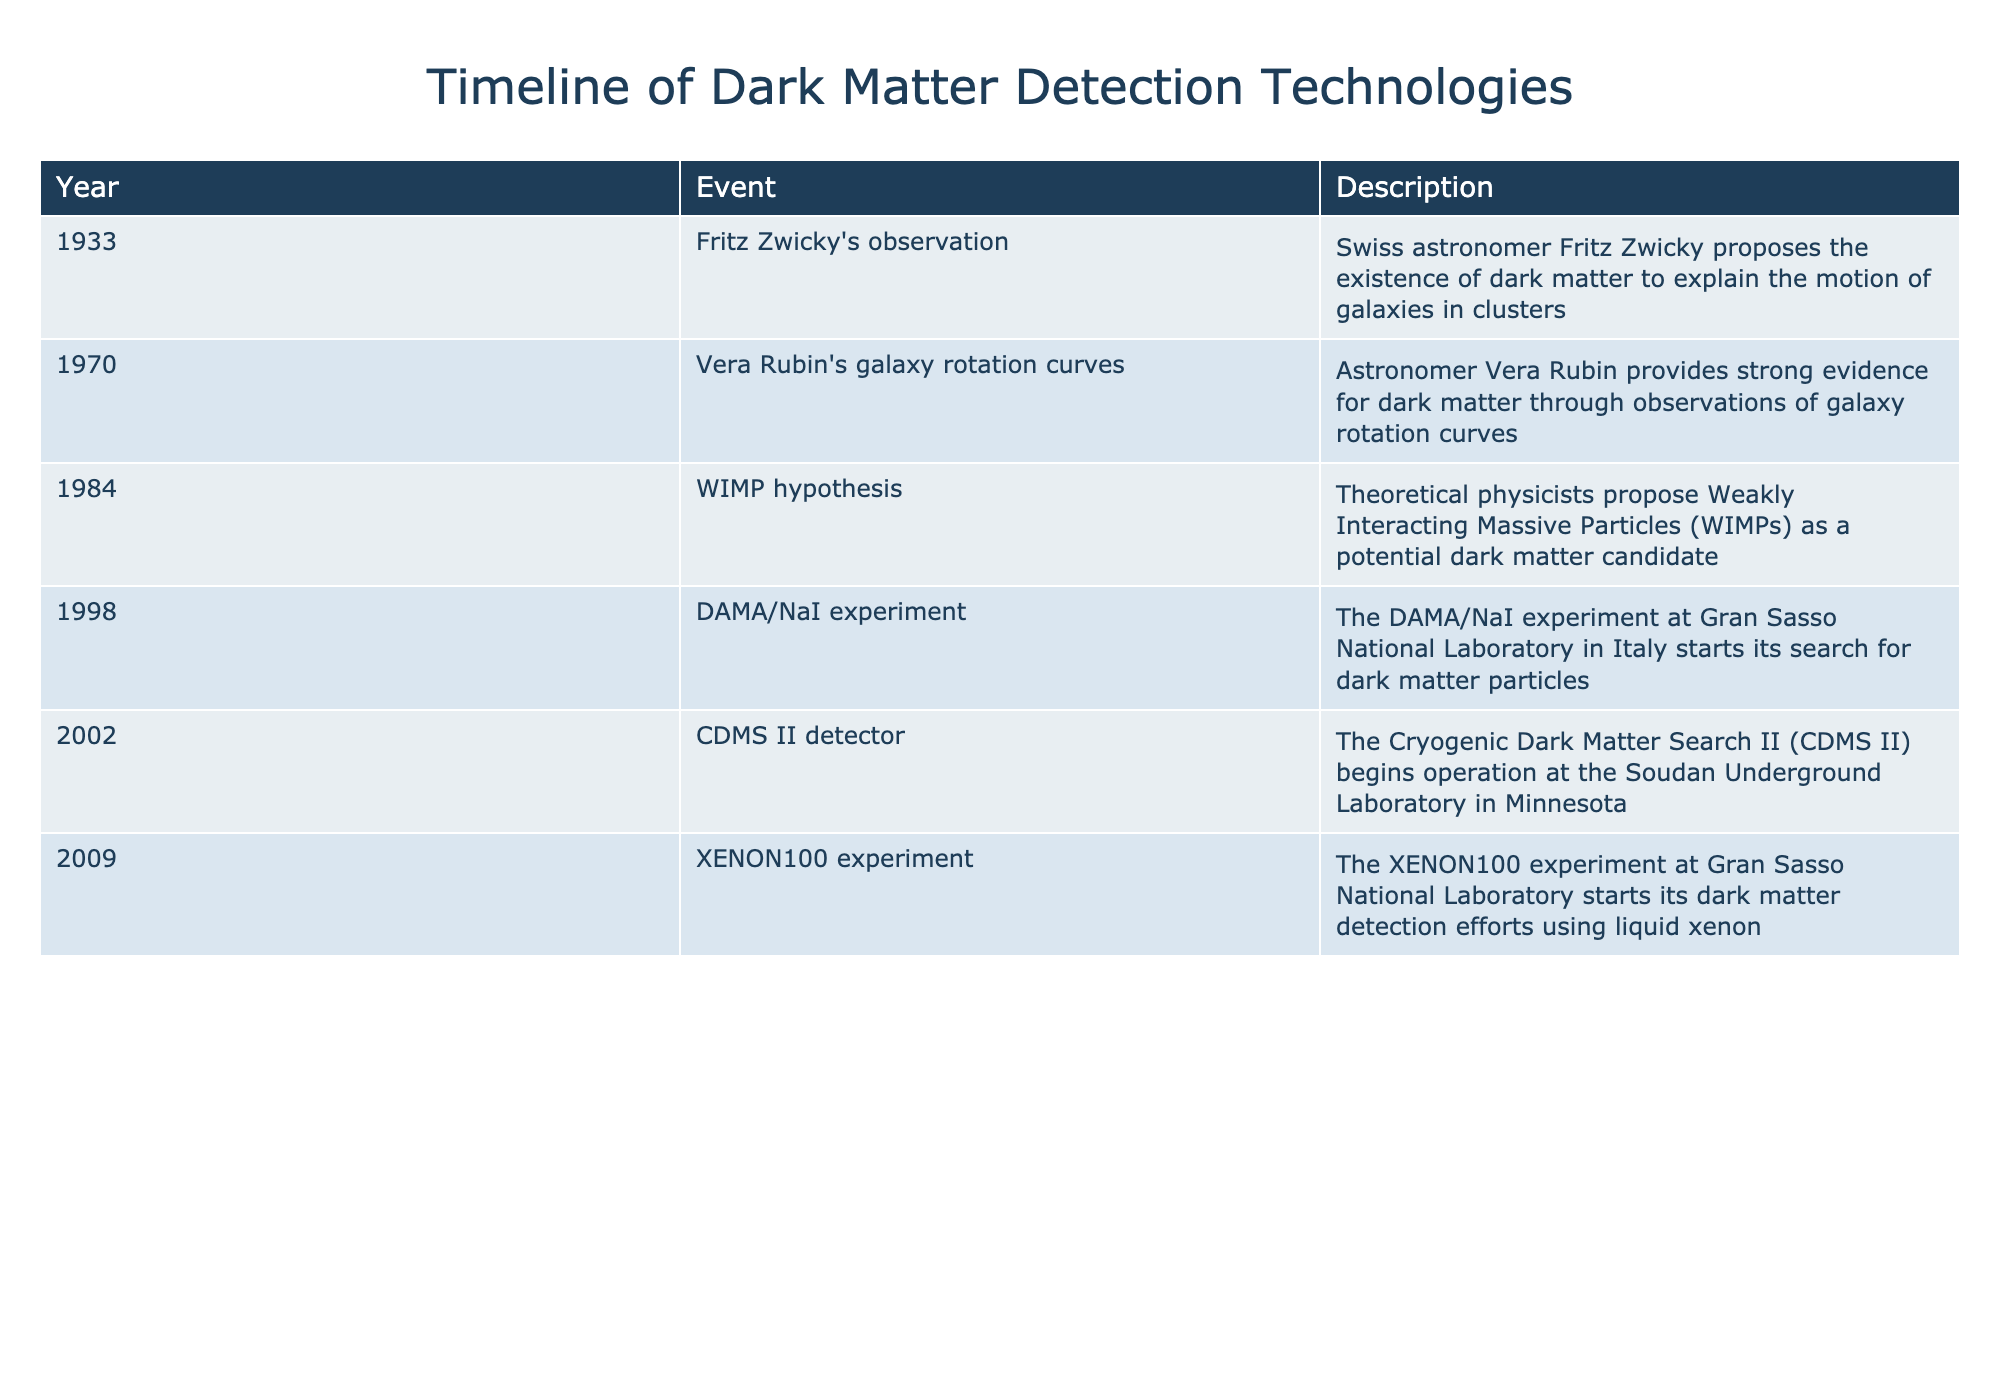What year did Fritz Zwicky propose the existence of dark matter? According to the table, Fritz Zwicky proposed the existence of dark matter in the year 1933.
Answer: 1933 What is the name of the experiment that started searching for dark matter particles in 1998? The table indicates that the DAMA/NaI experiment began in 1998 to search for dark matter particles.
Answer: DAMA/NaI experiment Which event occurred first, the WIMP hypothesis or the CDMS II detector operation? By looking at the years in the table, we can see that the WIMP hypothesis was proposed in 1984 and the CDMS II detector began operation in 2002. Since 1984 is earlier than 2002, the WIMP hypothesis occurred first.
Answer: WIMP hypothesis Is the XENON100 experiment associated with the Gran Sasso National Laboratory? Yes, the table shows that the XENON100 experiment, which began in 2009, is indeed associated with the Gran Sasso National Laboratory.
Answer: Yes How many years elapsed between the proposal of the WIMP hypothesis and the beginning of the DAMA/NaI experiment? The WIMP hypothesis was proposed in 1984, and the DAMA/NaI experiment started in 1998. To find the number of years that elapsed, we subtract 1984 from 1998: 1998 - 1984 = 14. Therefore, 14 years elapsed between these two events.
Answer: 14 years What was the purpose of Vera Rubin's observations made in 1970? Vera Rubin's observations in 1970 provided strong evidence for dark matter through her studies of galaxy rotation curves, as mentioned in the description column of the table.
Answer: Evidence for dark matter How many detection technologies were initiated or started operations between 1998 and 2009? Referring to the table, we see that there are two detection technologies that began within this range: the DAMA/NaI experiment in 1998 and the XENON100 experiment in 2009. Therefore, we can conclude there are two detection technologies initiated in that timeframe.
Answer: 2 Was the first detection technology mentioned in the table the DAMA/NaI experiment? No, the first detection technology mentioned in the table is Fritz Zwicky's observation in 1933, not the DAMA/NaI experiment, which started much later in 1998.
Answer: No Between which two events did the significant gap of advancements in dark matter detection occur as indicated in the table? The timeline shows a significant gap between 1984, when the WIMP hypothesis was proposed, and 1998, when the DAMA/NaI experiment began. This indicates a period of 14 years with no direct advancements listed in the table.
Answer: WIMP hypothesis and DAMA/NaI experiment 